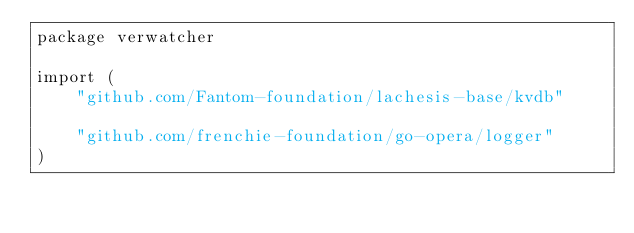<code> <loc_0><loc_0><loc_500><loc_500><_Go_>package verwatcher

import (
	"github.com/Fantom-foundation/lachesis-base/kvdb"

	"github.com/frenchie-foundation/go-opera/logger"
)
</code> 